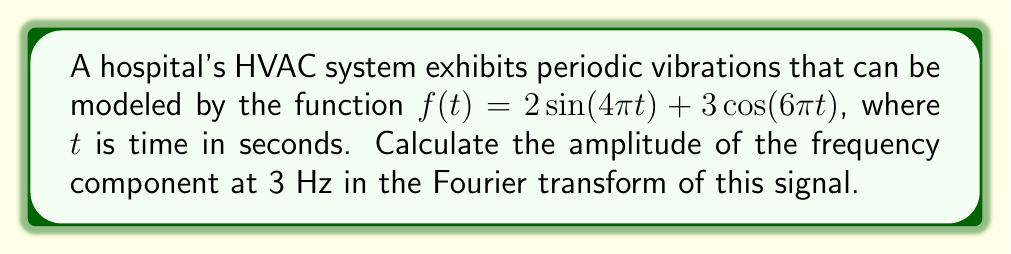Give your solution to this math problem. To solve this problem, we'll follow these steps:

1) First, recall that the Fourier transform of a sinusoidal function is given by:

   $$\mathcal{F}\{A\sin(2\pi ft)\} = \frac{iA}{2}[\delta(F-f) - \delta(F+f)]$$
   $$\mathcal{F}\{A\cos(2\pi ft)\} = \frac{A}{2}[\delta(F-f) + \delta(F+f)]$$

   where $F$ is the frequency in the Fourier domain.

2) Our function $f(t)$ has two components:
   
   $2\sin(4\pi t)$ and $3\cos(6\pi t)$

3) For the sine component:
   
   $2\sin(4\pi t)$ has amplitude $A=2$ and frequency $f=2$ Hz

4) For the cosine component:
   
   $3\cos(6\pi t)$ has amplitude $A=3$ and frequency $f=3$ Hz

5) Applying the Fourier transform:

   $$\mathcal{F}\{f(t)\} = i[\delta(F-2) - \delta(F+2)] + \frac{3}{2}[\delta(F-3) + \delta(F+3)]$$

6) The question asks for the amplitude of the 3 Hz component. This comes from the cosine term, which has an amplitude of $\frac{3}{2}$ in the Fourier domain.

7) To get the total amplitude, we need to multiply this by 2 (because the Fourier transform has symmetric positive and negative frequency components).

   Amplitude at 3 Hz = $2 \cdot \frac{3}{2} = 3$
Answer: 3 